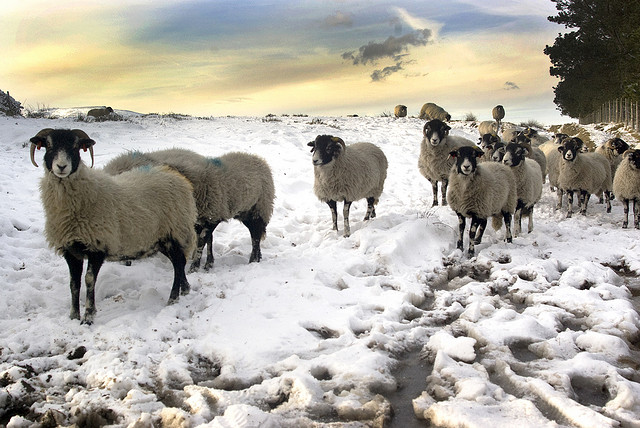<image>Where are they going? It is unknown where they are going. Where are they going? I don't know where they are going. It is unclear from the given information. 